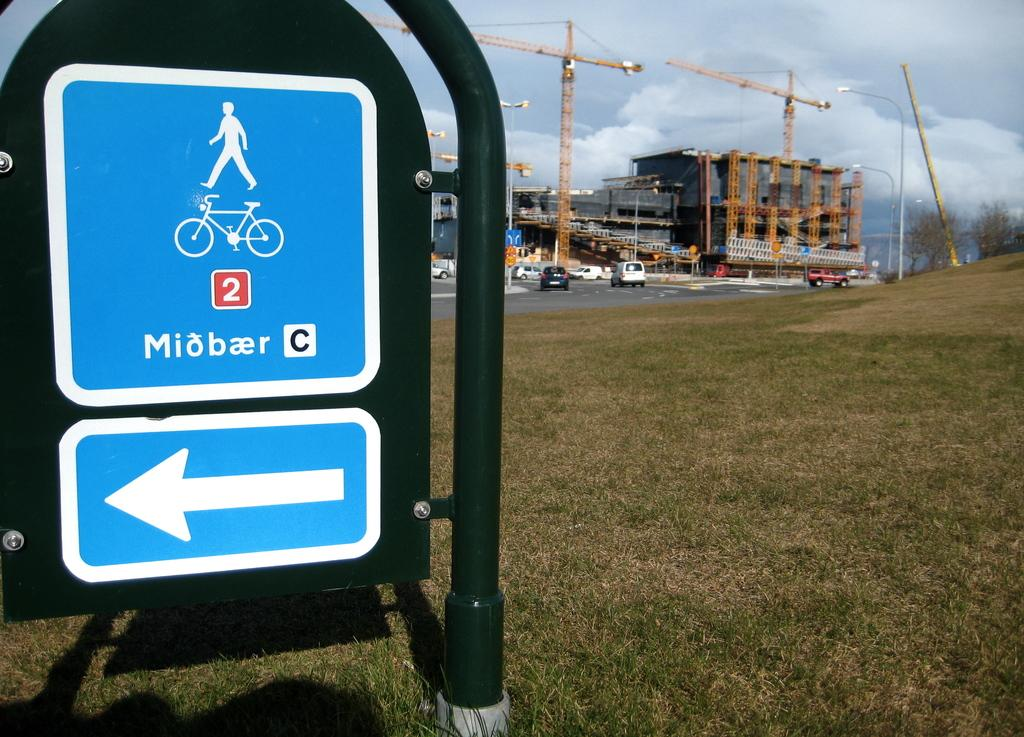<image>
Give a short and clear explanation of the subsequent image. A baby blue sign with a person and a bike on it and the word Miobaer. 